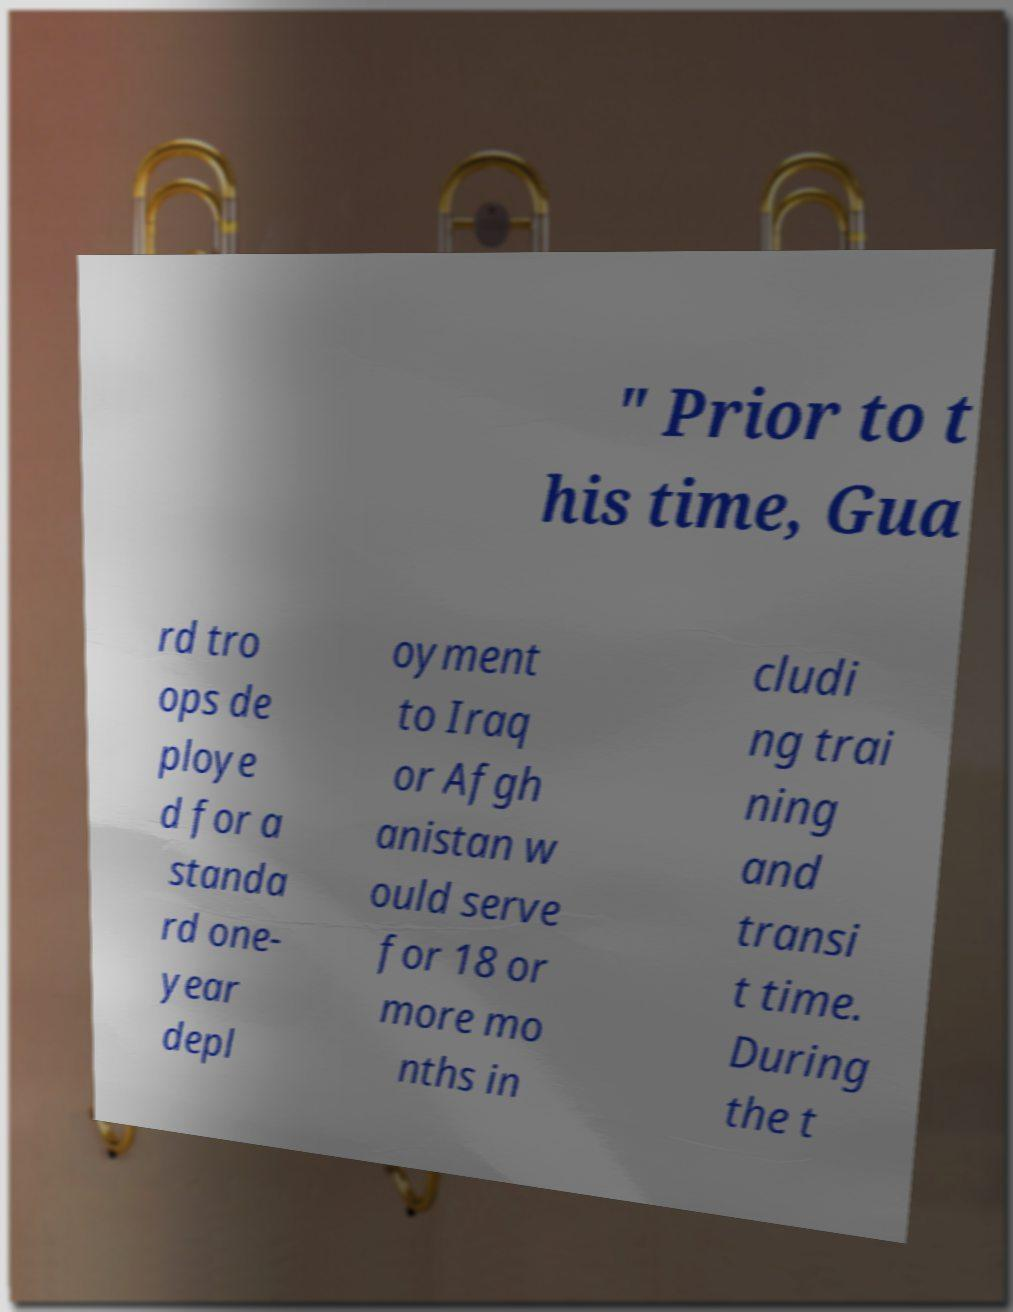For documentation purposes, I need the text within this image transcribed. Could you provide that? " Prior to t his time, Gua rd tro ops de ploye d for a standa rd one- year depl oyment to Iraq or Afgh anistan w ould serve for 18 or more mo nths in cludi ng trai ning and transi t time. During the t 